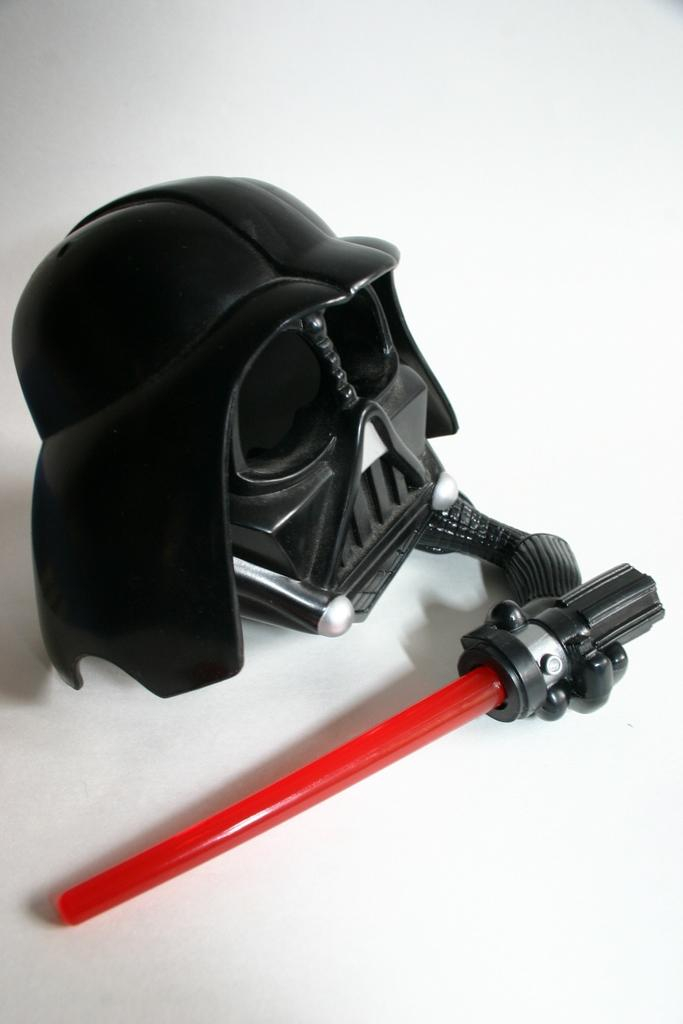What object can be seen in the image that is typically used for disguise or protection? There is a mask in the image. What other object is visible in the image? There is a stick in the image. What color is the surface on which the mask and stick are placed? The surface in the image is white. What level of credit is required to use the mask in the image? There is no mention of credit or any requirement related to credit in the image. The mask is simply an object that is visible. 